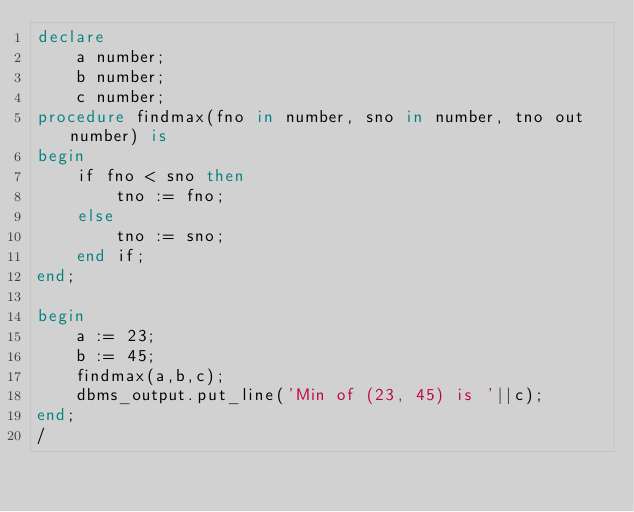<code> <loc_0><loc_0><loc_500><loc_500><_SQL_>declare 
    a number;
    b number;
    c number;
procedure findmax(fno in number, sno in number, tno out number) is
begin
    if fno < sno then
        tno := fno;
    else
        tno := sno;
    end if;
end;
    
begin
    a := 23;
    b := 45;
    findmax(a,b,c);
    dbms_output.put_line('Min of (23, 45) is '||c);
end;
/
</code> 